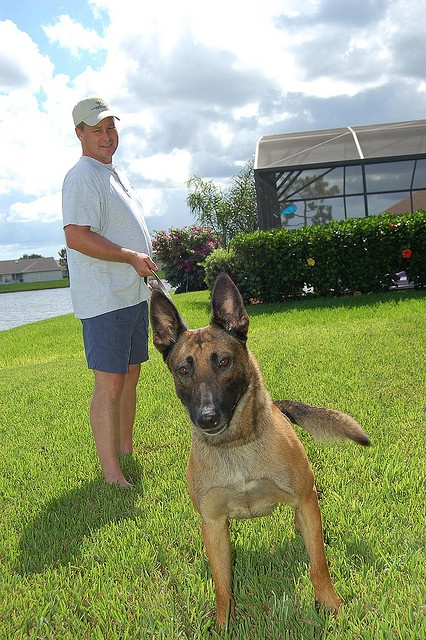Describe the objects in this image and their specific colors. I can see dog in lightblue, tan, gray, and olive tones and people in lightblue, darkgray, gray, white, and olive tones in this image. 